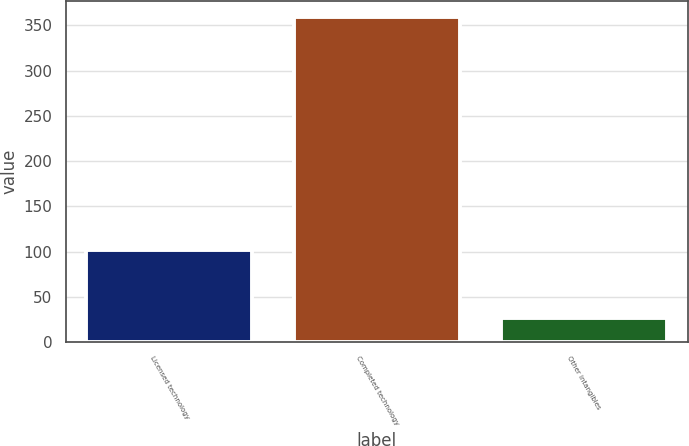Convert chart to OTSL. <chart><loc_0><loc_0><loc_500><loc_500><bar_chart><fcel>Licensed technology<fcel>Completed technology<fcel>Other intangibles<nl><fcel>102<fcel>359<fcel>27<nl></chart> 